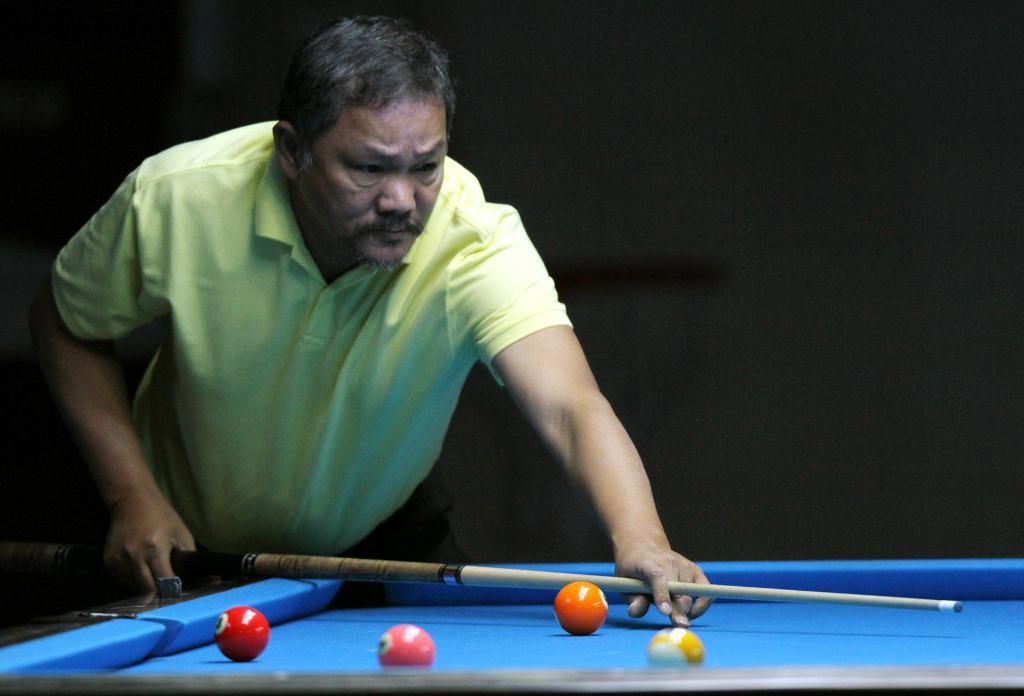Could you give a brief overview of what you see in this image? In this image, we can see a person who is wearing yellow T-shirt and he is holding a snooker stick in his hand and he is looking towards the table which is blue in color and the background is dark. 